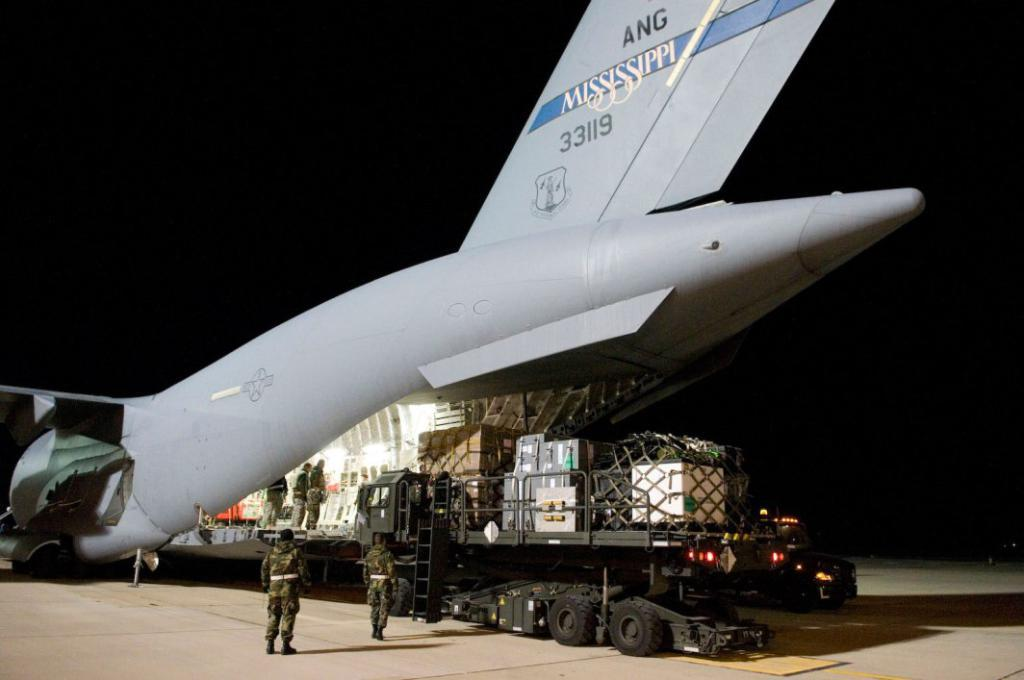What is the main subject of the image? The main subject of the image is an aeroplane. What other vehicle is present in the image? There is a truck in the image. Can you describe the people in the image? There are people in the image, but their specific actions or appearances are not mentioned in the facts. What is at the bottom of the image? There is a road at the bottom of the image. What is visible at the top of the image? There is sky visible at the top of the image. What type of leather is being used to make the wine in the image? There is no leather or wine present in the image; it features an aeroplane and a truck. How many tins of paint are visible on the truck in the image? There is no mention of tins or paint on the truck in the image; it only states that there is a truck present. 